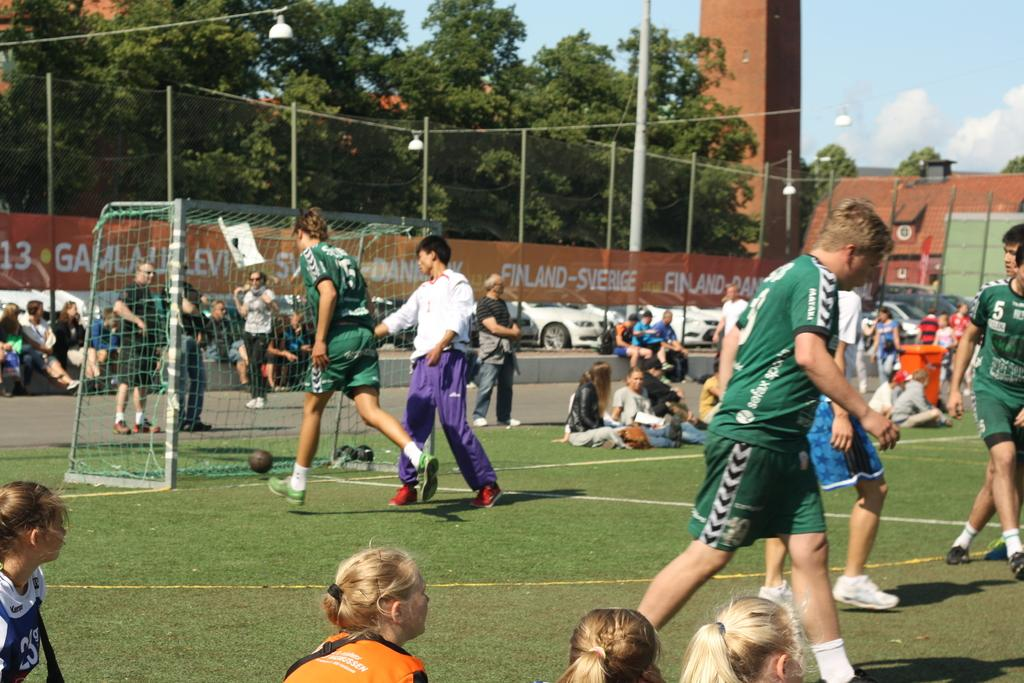<image>
Provide a brief description of the given image. Soccer players are on a field, with a banner for Finland-Sverige in the background. 